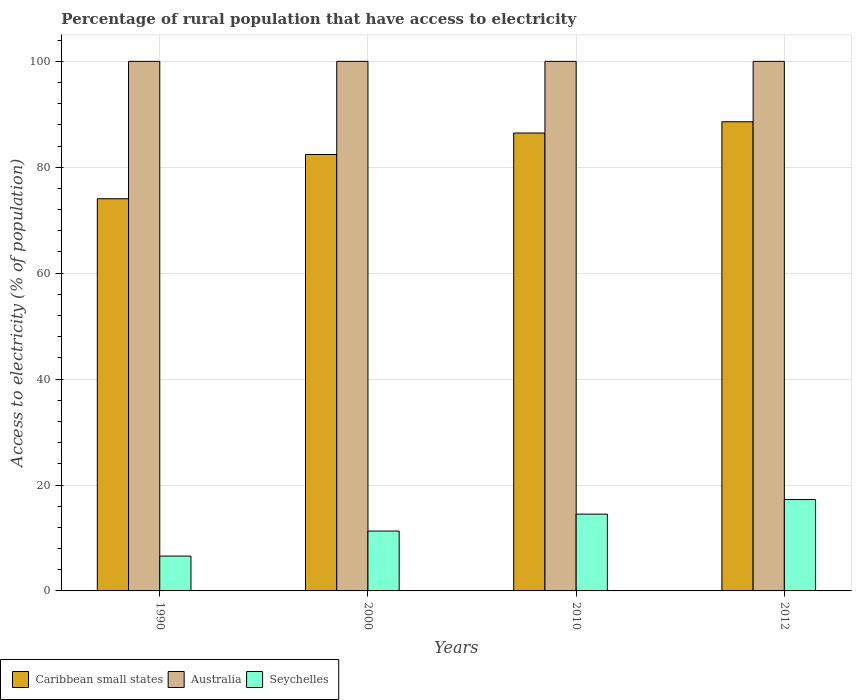How many different coloured bars are there?
Make the answer very short. 3. How many groups of bars are there?
Give a very brief answer. 4. Are the number of bars on each tick of the X-axis equal?
Give a very brief answer. Yes. How many bars are there on the 3rd tick from the left?
Your answer should be very brief. 3. How many bars are there on the 2nd tick from the right?
Your response must be concise. 3. What is the label of the 3rd group of bars from the left?
Provide a short and direct response. 2010. In how many cases, is the number of bars for a given year not equal to the number of legend labels?
Provide a succinct answer. 0. What is the percentage of rural population that have access to electricity in Caribbean small states in 1990?
Ensure brevity in your answer.  74.06. Across all years, what is the maximum percentage of rural population that have access to electricity in Caribbean small states?
Ensure brevity in your answer.  88.6. Across all years, what is the minimum percentage of rural population that have access to electricity in Seychelles?
Your answer should be very brief. 6.58. In which year was the percentage of rural population that have access to electricity in Caribbean small states maximum?
Your response must be concise. 2012. What is the total percentage of rural population that have access to electricity in Caribbean small states in the graph?
Your response must be concise. 331.54. What is the difference between the percentage of rural population that have access to electricity in Seychelles in 2012 and the percentage of rural population that have access to electricity in Australia in 1990?
Keep it short and to the point. -82.75. What is the average percentage of rural population that have access to electricity in Caribbean small states per year?
Make the answer very short. 82.89. In the year 2010, what is the difference between the percentage of rural population that have access to electricity in Caribbean small states and percentage of rural population that have access to electricity in Seychelles?
Offer a very short reply. 71.97. What is the ratio of the percentage of rural population that have access to electricity in Caribbean small states in 1990 to that in 2010?
Offer a terse response. 0.86. Is the percentage of rural population that have access to electricity in Caribbean small states in 1990 less than that in 2010?
Your answer should be very brief. Yes. Is the difference between the percentage of rural population that have access to electricity in Caribbean small states in 2000 and 2010 greater than the difference between the percentage of rural population that have access to electricity in Seychelles in 2000 and 2010?
Offer a terse response. No. What is the difference between the highest and the second highest percentage of rural population that have access to electricity in Caribbean small states?
Make the answer very short. 2.13. What is the difference between the highest and the lowest percentage of rural population that have access to electricity in Caribbean small states?
Offer a terse response. 14.54. In how many years, is the percentage of rural population that have access to electricity in Australia greater than the average percentage of rural population that have access to electricity in Australia taken over all years?
Your answer should be compact. 0. Is the sum of the percentage of rural population that have access to electricity in Seychelles in 2000 and 2012 greater than the maximum percentage of rural population that have access to electricity in Caribbean small states across all years?
Your answer should be compact. No. What does the 3rd bar from the left in 2000 represents?
Offer a very short reply. Seychelles. What does the 1st bar from the right in 2012 represents?
Your response must be concise. Seychelles. How many bars are there?
Provide a short and direct response. 12. How many years are there in the graph?
Provide a succinct answer. 4. What is the difference between two consecutive major ticks on the Y-axis?
Offer a very short reply. 20. Are the values on the major ticks of Y-axis written in scientific E-notation?
Give a very brief answer. No. Does the graph contain grids?
Ensure brevity in your answer.  Yes. How are the legend labels stacked?
Make the answer very short. Horizontal. What is the title of the graph?
Keep it short and to the point. Percentage of rural population that have access to electricity. What is the label or title of the Y-axis?
Provide a short and direct response. Access to electricity (% of population). What is the Access to electricity (% of population) in Caribbean small states in 1990?
Make the answer very short. 74.06. What is the Access to electricity (% of population) of Seychelles in 1990?
Your response must be concise. 6.58. What is the Access to electricity (% of population) of Caribbean small states in 2000?
Provide a succinct answer. 82.42. What is the Access to electricity (% of population) in Seychelles in 2000?
Your answer should be compact. 11.3. What is the Access to electricity (% of population) of Caribbean small states in 2010?
Provide a short and direct response. 86.47. What is the Access to electricity (% of population) in Seychelles in 2010?
Your response must be concise. 14.5. What is the Access to electricity (% of population) of Caribbean small states in 2012?
Offer a very short reply. 88.6. What is the Access to electricity (% of population) of Seychelles in 2012?
Provide a short and direct response. 17.25. Across all years, what is the maximum Access to electricity (% of population) of Caribbean small states?
Provide a succinct answer. 88.6. Across all years, what is the maximum Access to electricity (% of population) in Seychelles?
Keep it short and to the point. 17.25. Across all years, what is the minimum Access to electricity (% of population) in Caribbean small states?
Your answer should be very brief. 74.06. Across all years, what is the minimum Access to electricity (% of population) in Australia?
Make the answer very short. 100. Across all years, what is the minimum Access to electricity (% of population) in Seychelles?
Offer a terse response. 6.58. What is the total Access to electricity (% of population) in Caribbean small states in the graph?
Make the answer very short. 331.54. What is the total Access to electricity (% of population) in Seychelles in the graph?
Provide a short and direct response. 49.64. What is the difference between the Access to electricity (% of population) of Caribbean small states in 1990 and that in 2000?
Provide a succinct answer. -8.36. What is the difference between the Access to electricity (% of population) in Seychelles in 1990 and that in 2000?
Make the answer very short. -4.72. What is the difference between the Access to electricity (% of population) in Caribbean small states in 1990 and that in 2010?
Offer a terse response. -12.41. What is the difference between the Access to electricity (% of population) in Australia in 1990 and that in 2010?
Give a very brief answer. 0. What is the difference between the Access to electricity (% of population) of Seychelles in 1990 and that in 2010?
Your answer should be compact. -7.92. What is the difference between the Access to electricity (% of population) in Caribbean small states in 1990 and that in 2012?
Your answer should be compact. -14.54. What is the difference between the Access to electricity (% of population) in Seychelles in 1990 and that in 2012?
Your response must be concise. -10.68. What is the difference between the Access to electricity (% of population) in Caribbean small states in 2000 and that in 2010?
Provide a succinct answer. -4.05. What is the difference between the Access to electricity (% of population) in Seychelles in 2000 and that in 2010?
Your answer should be compact. -3.2. What is the difference between the Access to electricity (% of population) of Caribbean small states in 2000 and that in 2012?
Keep it short and to the point. -6.18. What is the difference between the Access to electricity (% of population) in Australia in 2000 and that in 2012?
Give a very brief answer. 0. What is the difference between the Access to electricity (% of population) of Seychelles in 2000 and that in 2012?
Keep it short and to the point. -5.95. What is the difference between the Access to electricity (% of population) in Caribbean small states in 2010 and that in 2012?
Provide a short and direct response. -2.13. What is the difference between the Access to electricity (% of population) of Australia in 2010 and that in 2012?
Make the answer very short. 0. What is the difference between the Access to electricity (% of population) of Seychelles in 2010 and that in 2012?
Ensure brevity in your answer.  -2.75. What is the difference between the Access to electricity (% of population) of Caribbean small states in 1990 and the Access to electricity (% of population) of Australia in 2000?
Keep it short and to the point. -25.94. What is the difference between the Access to electricity (% of population) in Caribbean small states in 1990 and the Access to electricity (% of population) in Seychelles in 2000?
Ensure brevity in your answer.  62.75. What is the difference between the Access to electricity (% of population) in Australia in 1990 and the Access to electricity (% of population) in Seychelles in 2000?
Provide a succinct answer. 88.7. What is the difference between the Access to electricity (% of population) of Caribbean small states in 1990 and the Access to electricity (% of population) of Australia in 2010?
Give a very brief answer. -25.94. What is the difference between the Access to electricity (% of population) in Caribbean small states in 1990 and the Access to electricity (% of population) in Seychelles in 2010?
Offer a terse response. 59.56. What is the difference between the Access to electricity (% of population) in Australia in 1990 and the Access to electricity (% of population) in Seychelles in 2010?
Offer a terse response. 85.5. What is the difference between the Access to electricity (% of population) of Caribbean small states in 1990 and the Access to electricity (% of population) of Australia in 2012?
Your answer should be compact. -25.94. What is the difference between the Access to electricity (% of population) of Caribbean small states in 1990 and the Access to electricity (% of population) of Seychelles in 2012?
Your answer should be very brief. 56.8. What is the difference between the Access to electricity (% of population) of Australia in 1990 and the Access to electricity (% of population) of Seychelles in 2012?
Offer a very short reply. 82.75. What is the difference between the Access to electricity (% of population) in Caribbean small states in 2000 and the Access to electricity (% of population) in Australia in 2010?
Give a very brief answer. -17.58. What is the difference between the Access to electricity (% of population) in Caribbean small states in 2000 and the Access to electricity (% of population) in Seychelles in 2010?
Your answer should be very brief. 67.92. What is the difference between the Access to electricity (% of population) of Australia in 2000 and the Access to electricity (% of population) of Seychelles in 2010?
Your answer should be very brief. 85.5. What is the difference between the Access to electricity (% of population) in Caribbean small states in 2000 and the Access to electricity (% of population) in Australia in 2012?
Offer a very short reply. -17.58. What is the difference between the Access to electricity (% of population) in Caribbean small states in 2000 and the Access to electricity (% of population) in Seychelles in 2012?
Keep it short and to the point. 65.16. What is the difference between the Access to electricity (% of population) of Australia in 2000 and the Access to electricity (% of population) of Seychelles in 2012?
Your response must be concise. 82.75. What is the difference between the Access to electricity (% of population) of Caribbean small states in 2010 and the Access to electricity (% of population) of Australia in 2012?
Ensure brevity in your answer.  -13.53. What is the difference between the Access to electricity (% of population) of Caribbean small states in 2010 and the Access to electricity (% of population) of Seychelles in 2012?
Offer a very short reply. 69.22. What is the difference between the Access to electricity (% of population) of Australia in 2010 and the Access to electricity (% of population) of Seychelles in 2012?
Your answer should be compact. 82.75. What is the average Access to electricity (% of population) of Caribbean small states per year?
Your answer should be compact. 82.89. What is the average Access to electricity (% of population) in Australia per year?
Offer a terse response. 100. What is the average Access to electricity (% of population) of Seychelles per year?
Your answer should be very brief. 12.41. In the year 1990, what is the difference between the Access to electricity (% of population) in Caribbean small states and Access to electricity (% of population) in Australia?
Provide a succinct answer. -25.94. In the year 1990, what is the difference between the Access to electricity (% of population) of Caribbean small states and Access to electricity (% of population) of Seychelles?
Give a very brief answer. 67.48. In the year 1990, what is the difference between the Access to electricity (% of population) of Australia and Access to electricity (% of population) of Seychelles?
Make the answer very short. 93.42. In the year 2000, what is the difference between the Access to electricity (% of population) of Caribbean small states and Access to electricity (% of population) of Australia?
Your answer should be compact. -17.58. In the year 2000, what is the difference between the Access to electricity (% of population) in Caribbean small states and Access to electricity (% of population) in Seychelles?
Give a very brief answer. 71.11. In the year 2000, what is the difference between the Access to electricity (% of population) of Australia and Access to electricity (% of population) of Seychelles?
Offer a terse response. 88.7. In the year 2010, what is the difference between the Access to electricity (% of population) in Caribbean small states and Access to electricity (% of population) in Australia?
Provide a short and direct response. -13.53. In the year 2010, what is the difference between the Access to electricity (% of population) in Caribbean small states and Access to electricity (% of population) in Seychelles?
Keep it short and to the point. 71.97. In the year 2010, what is the difference between the Access to electricity (% of population) in Australia and Access to electricity (% of population) in Seychelles?
Give a very brief answer. 85.5. In the year 2012, what is the difference between the Access to electricity (% of population) of Caribbean small states and Access to electricity (% of population) of Australia?
Provide a succinct answer. -11.4. In the year 2012, what is the difference between the Access to electricity (% of population) of Caribbean small states and Access to electricity (% of population) of Seychelles?
Your answer should be compact. 71.34. In the year 2012, what is the difference between the Access to electricity (% of population) of Australia and Access to electricity (% of population) of Seychelles?
Keep it short and to the point. 82.75. What is the ratio of the Access to electricity (% of population) in Caribbean small states in 1990 to that in 2000?
Your answer should be compact. 0.9. What is the ratio of the Access to electricity (% of population) in Australia in 1990 to that in 2000?
Provide a succinct answer. 1. What is the ratio of the Access to electricity (% of population) of Seychelles in 1990 to that in 2000?
Offer a very short reply. 0.58. What is the ratio of the Access to electricity (% of population) in Caribbean small states in 1990 to that in 2010?
Offer a very short reply. 0.86. What is the ratio of the Access to electricity (% of population) in Australia in 1990 to that in 2010?
Provide a succinct answer. 1. What is the ratio of the Access to electricity (% of population) of Seychelles in 1990 to that in 2010?
Your answer should be very brief. 0.45. What is the ratio of the Access to electricity (% of population) of Caribbean small states in 1990 to that in 2012?
Offer a very short reply. 0.84. What is the ratio of the Access to electricity (% of population) of Australia in 1990 to that in 2012?
Your answer should be very brief. 1. What is the ratio of the Access to electricity (% of population) in Seychelles in 1990 to that in 2012?
Ensure brevity in your answer.  0.38. What is the ratio of the Access to electricity (% of population) of Caribbean small states in 2000 to that in 2010?
Provide a short and direct response. 0.95. What is the ratio of the Access to electricity (% of population) in Seychelles in 2000 to that in 2010?
Offer a very short reply. 0.78. What is the ratio of the Access to electricity (% of population) of Caribbean small states in 2000 to that in 2012?
Ensure brevity in your answer.  0.93. What is the ratio of the Access to electricity (% of population) of Australia in 2000 to that in 2012?
Offer a terse response. 1. What is the ratio of the Access to electricity (% of population) of Seychelles in 2000 to that in 2012?
Ensure brevity in your answer.  0.66. What is the ratio of the Access to electricity (% of population) in Seychelles in 2010 to that in 2012?
Your answer should be compact. 0.84. What is the difference between the highest and the second highest Access to electricity (% of population) of Caribbean small states?
Your response must be concise. 2.13. What is the difference between the highest and the second highest Access to electricity (% of population) in Australia?
Your answer should be compact. 0. What is the difference between the highest and the second highest Access to electricity (% of population) in Seychelles?
Your answer should be very brief. 2.75. What is the difference between the highest and the lowest Access to electricity (% of population) in Caribbean small states?
Ensure brevity in your answer.  14.54. What is the difference between the highest and the lowest Access to electricity (% of population) in Australia?
Provide a short and direct response. 0. What is the difference between the highest and the lowest Access to electricity (% of population) of Seychelles?
Offer a terse response. 10.68. 